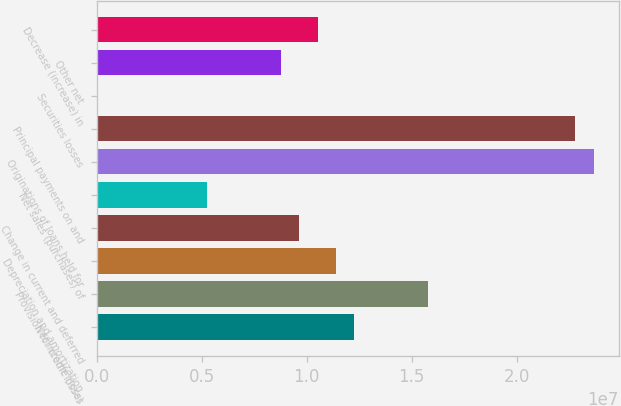<chart> <loc_0><loc_0><loc_500><loc_500><bar_chart><fcel>Net income (loss)<fcel>Provision for credit losses<fcel>Depreciation and amortization<fcel>Change in current and deferred<fcel>Net sales (purchases) of<fcel>Originations of loans held for<fcel>Principal payments on and<fcel>Securities losses<fcel>Other net<fcel>Decrease (increase) in<nl><fcel>1.22776e+07<fcel>1.57854e+07<fcel>1.14006e+07<fcel>9.64672e+06<fcel>5.26197e+06<fcel>2.36779e+07<fcel>2.2801e+07<fcel>274<fcel>8.76977e+06<fcel>1.05237e+07<nl></chart> 